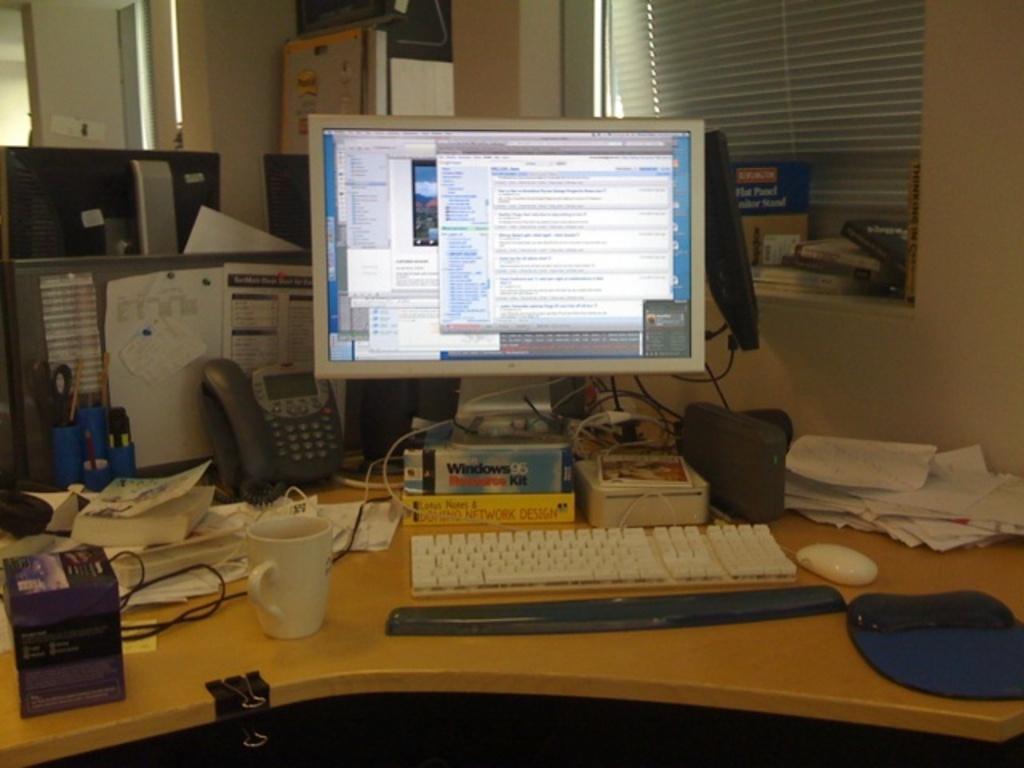Could you give a brief overview of what you see in this image? there is a computer on a table which has a cable and a mouse. behind that there are papers, books, glass, phone. 